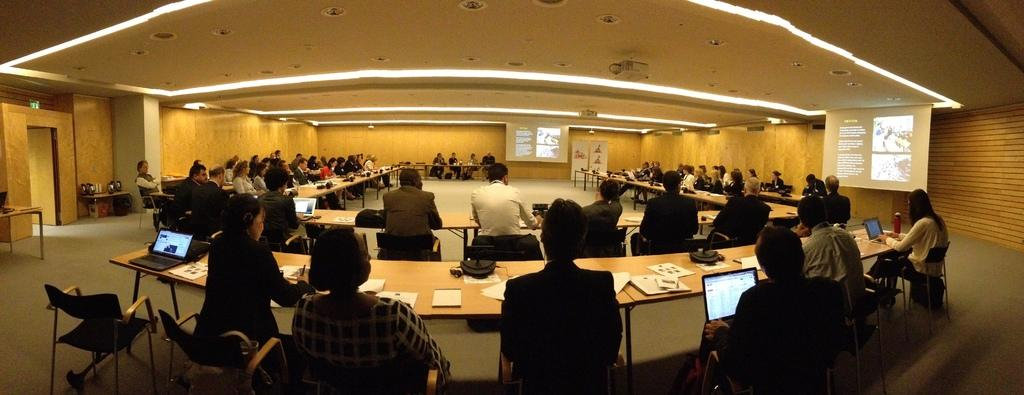How many people are in the image? There is a group of people in the image. Where are the people located in the image? The people are sitting in a room. What furniture is present in the room? There are tables in the room. What are the people doing in the image? The people are operating laptops. What type of farm animals can be seen in the image? There are no farm animals present in the image. 